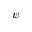<formula> <loc_0><loc_0><loc_500><loc_500>\psi</formula> 